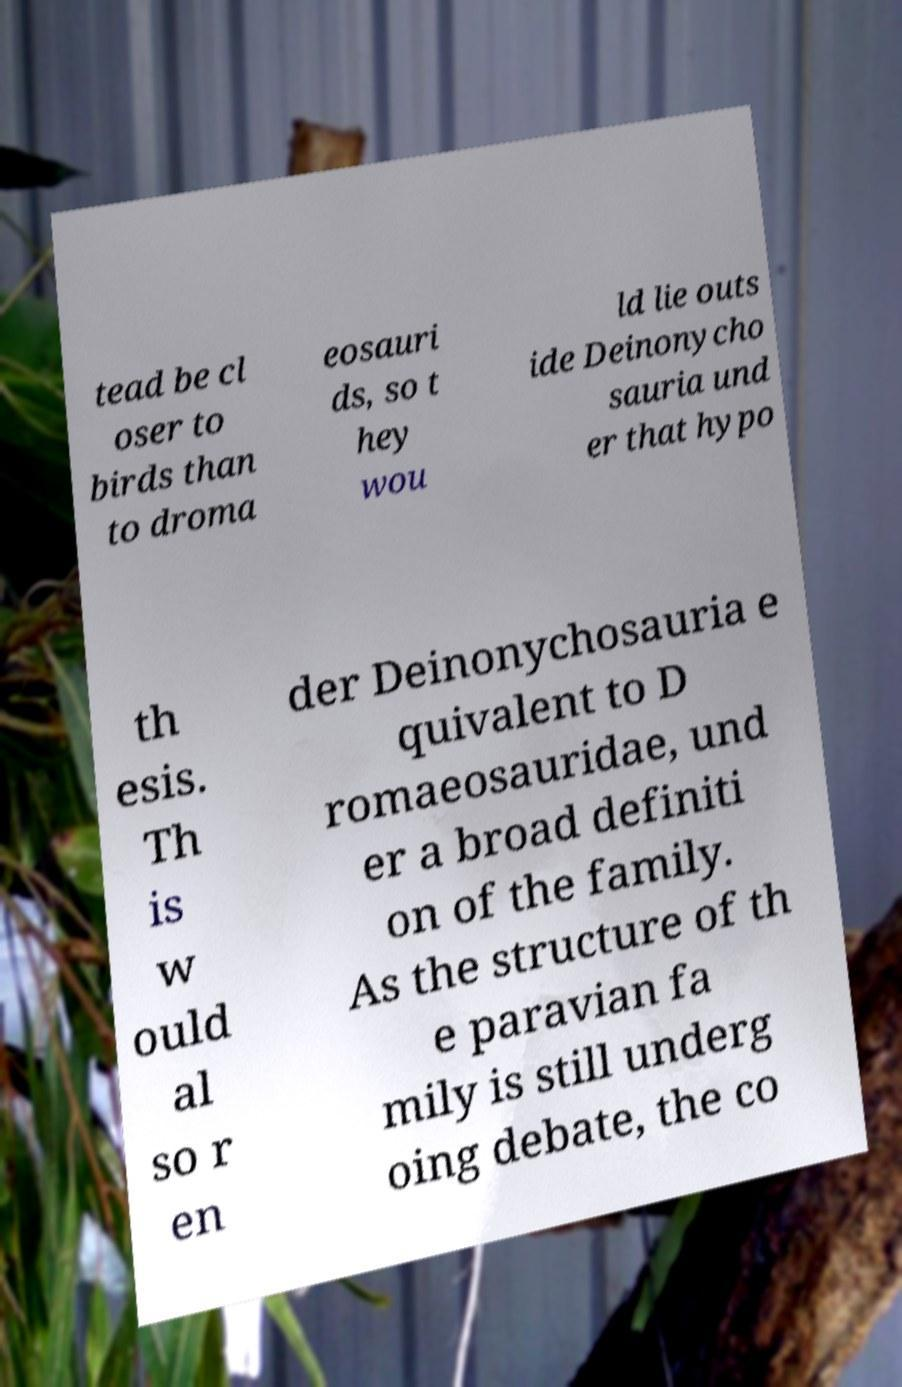What messages or text are displayed in this image? I need them in a readable, typed format. tead be cl oser to birds than to droma eosauri ds, so t hey wou ld lie outs ide Deinonycho sauria und er that hypo th esis. Th is w ould al so r en der Deinonychosauria e quivalent to D romaeosauridae, und er a broad definiti on of the family. As the structure of th e paravian fa mily is still underg oing debate, the co 